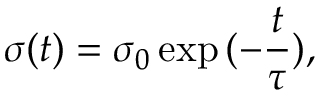Convert formula to latex. <formula><loc_0><loc_0><loc_500><loc_500>\sigma ( t ) = \sigma _ { 0 } \exp { ( - \frac { t } { \tau } ) } ,</formula> 